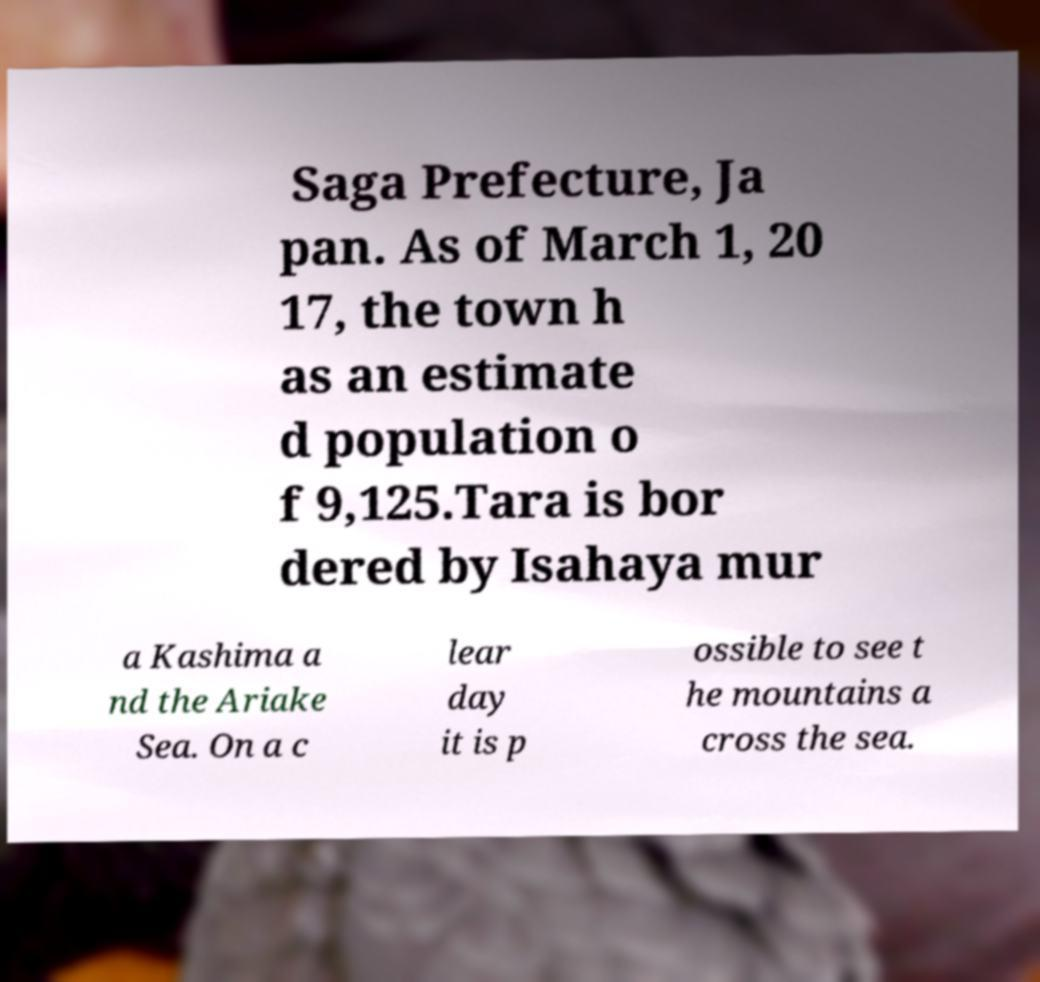What messages or text are displayed in this image? I need them in a readable, typed format. Saga Prefecture, Ja pan. As of March 1, 20 17, the town h as an estimate d population o f 9,125.Tara is bor dered by Isahaya mur a Kashima a nd the Ariake Sea. On a c lear day it is p ossible to see t he mountains a cross the sea. 